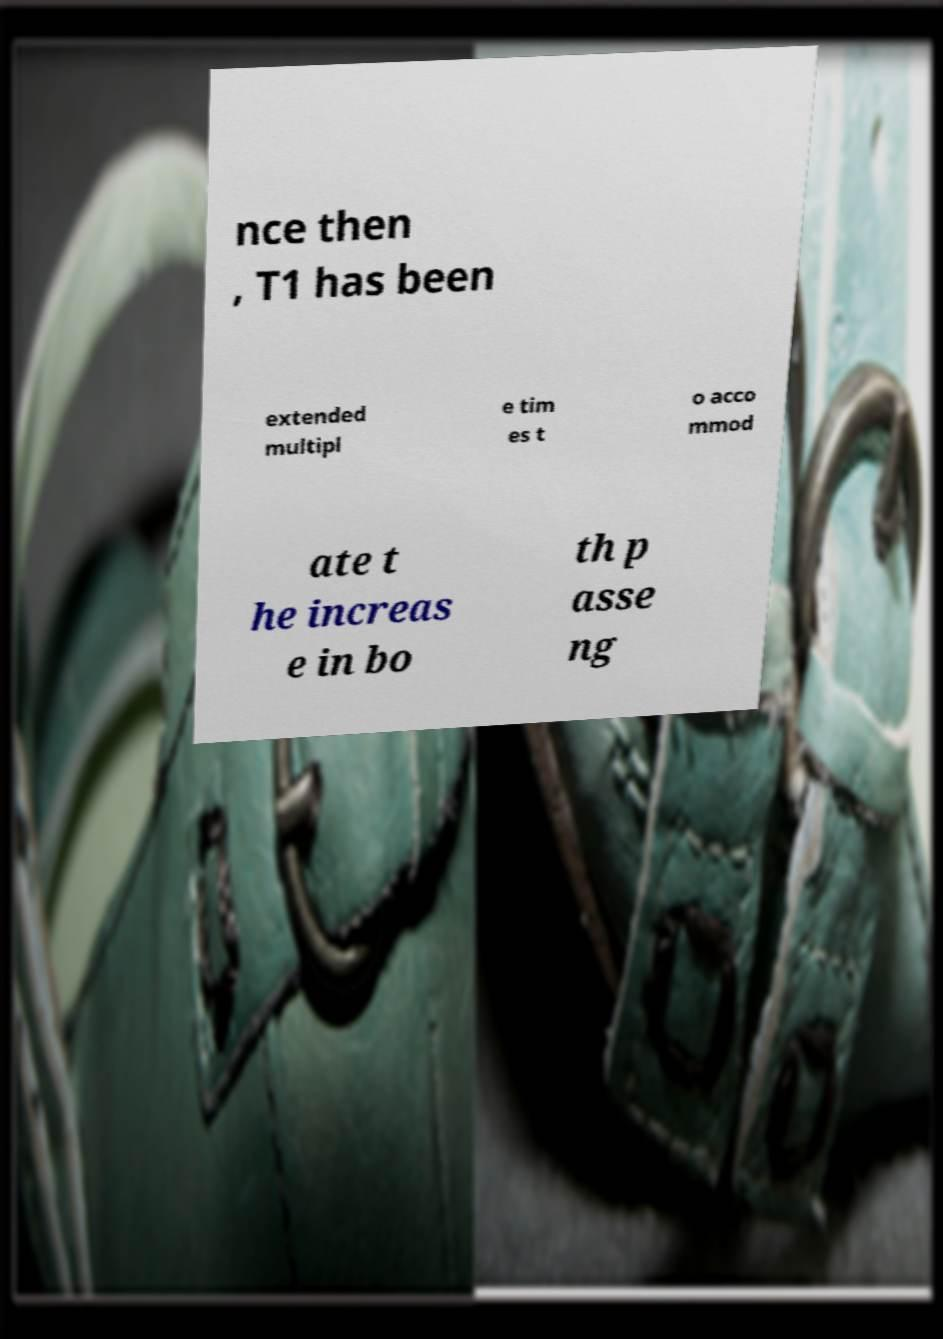For documentation purposes, I need the text within this image transcribed. Could you provide that? nce then , T1 has been extended multipl e tim es t o acco mmod ate t he increas e in bo th p asse ng 